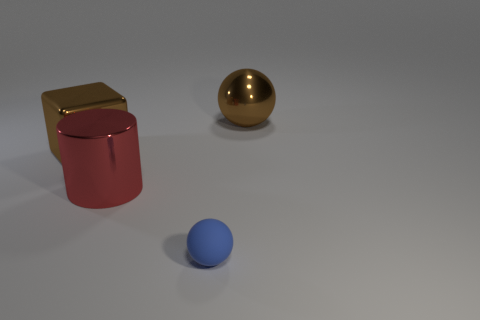Is there any other thing that is made of the same material as the tiny blue object?
Your answer should be compact. No. Is the big ball the same color as the large block?
Offer a very short reply. Yes. There is a object that is to the right of the red cylinder and to the left of the metallic sphere; what is its size?
Offer a very short reply. Small. There is a shiny object that is to the right of the small blue matte object; are there any small blue rubber objects that are on the right side of it?
Your answer should be very brief. No. How many metal balls are behind the brown block?
Offer a very short reply. 1. There is a large metallic object that is the same shape as the tiny blue thing; what is its color?
Keep it short and to the point. Brown. Do the big brown thing left of the big cylinder and the ball that is behind the big brown cube have the same material?
Offer a terse response. Yes. There is a shiny ball; is its color the same as the block to the left of the tiny rubber thing?
Ensure brevity in your answer.  Yes. What is the shape of the object that is behind the rubber ball and right of the red shiny object?
Your response must be concise. Sphere. How many cubes are there?
Provide a succinct answer. 1. 